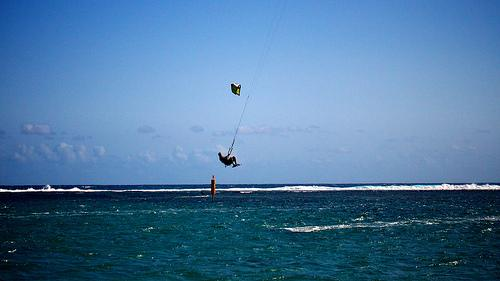How would you describe the sentiment or emotion conveyed by the image?  The image conveys a sense of adventure, freedom, and exhilaration, as the man enjoys paragliding above the ocean. Based on the position and sizes provided, assess the overall image quality in terms of the objects' visibility and clarity. The image has a decent quality, with most objects having proper sizes and visible positions, allowing for clear identification and understanding of the scene. 